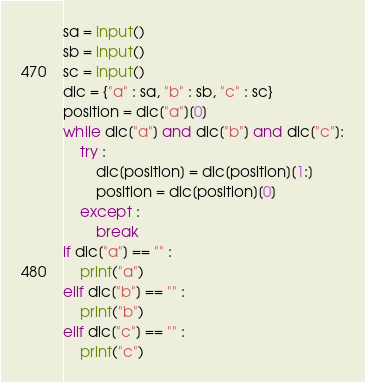Convert code to text. <code><loc_0><loc_0><loc_500><loc_500><_Python_>sa = input()
sb = input()
sc = input()
dic = {"a" : sa, "b" : sb, "c" : sc}
position = dic["a"][0]
while dic["a"] and dic["b"] and dic["c"]:
    try :
        dic[position] = dic[position][1:]
        position = dic[position][0]
    except :
        break
if dic["a"] == "" :
    print("a")
elif dic["b"] == "" :
    print("b")
elif dic["c"] == "" :
    print("c")</code> 